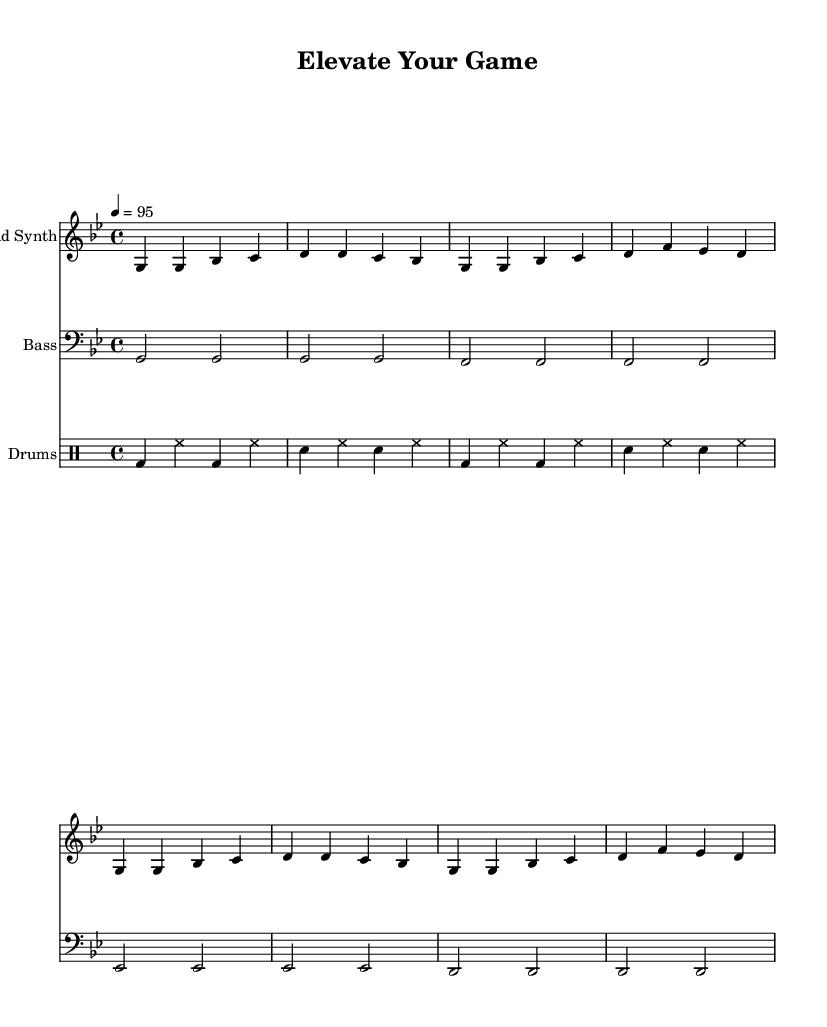What is the key signature of this music? The key signature is G minor, which includes two flats (B♭ and E♭). This can be identified by looking at the key signature notation at the beginning of the staff.
Answer: G minor What is the time signature of this music? The time signature is 4/4, which indicates four beats per measure and that a quarter note receives one beat. This is shown at the beginning of the sheet music near the key signature.
Answer: 4/4 What is the tempo marking for this piece? The tempo marking is 4 = 95, which specifies the speed of the music and indicates that there are 95 beats per minute. This marking is typically found at the start of the score, right after the key and time signature.
Answer: 95 How many measures are there in the lead synth part? There are eight measures in the lead synth part, visually counted by the number of distinct measures on the staff where separate vertical lines divide them.
Answer: 8 Which instrument plays the bass line? The bass line is played by the Bass instrument, which is indicated at the start of the corresponding staff section. The clef specifically shows that it is meant for a bass part.
Answer: Bass What rhythmic pattern is used in the drums section? The rhythmic pattern consists of a basic alternating kick and snare drum rhythm that is typical in hip-hop. This can be inferred by analyzing the drum notation, where bass drum hits alternate with snare drum hits.
Answer: Alternating kick and snare What overall genre does this composition represent? The overall genre represented by this composition is Hip Hop, indicated by the high-energy nature and the use of specific rhythmic patterns and motivational melodies that are characteristic of hip-hop music.
Answer: Hip Hop 